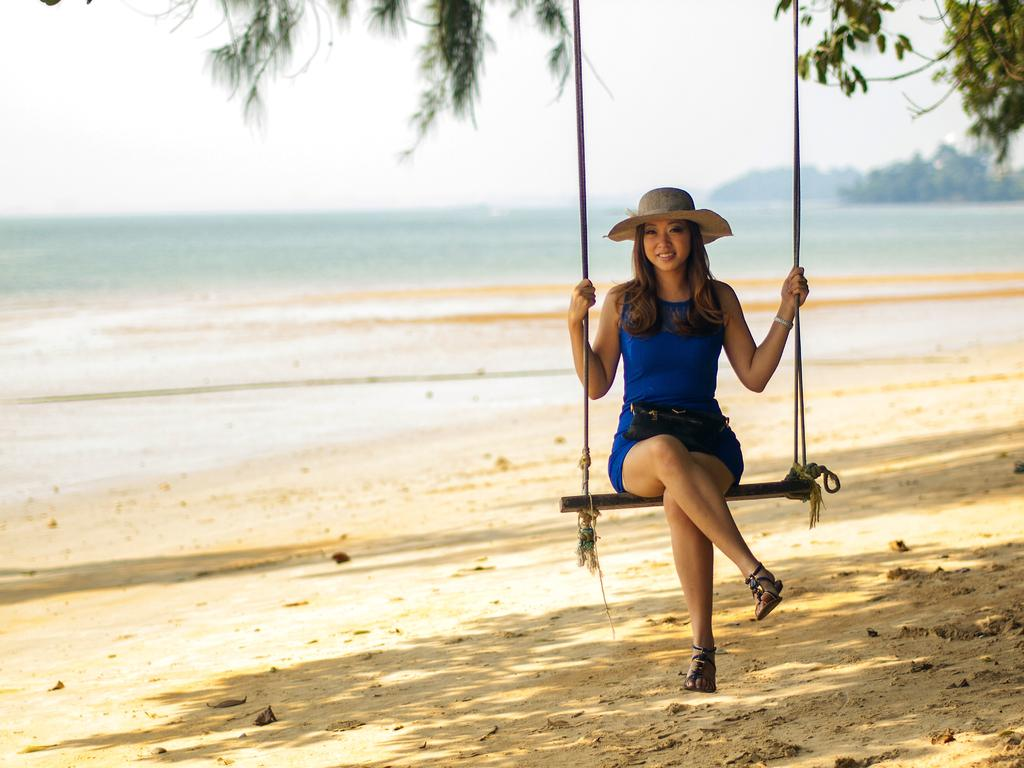What is the woman in the image doing? The woman is sitting in the swing in the image. What is the woman wearing on her head? The woman is wearing a hat. What type of terrain can be seen in the background of the image? There is sand, water, and hills visible in the background of the image. What part of the natural environment is visible in the image? The sky is visible in the background of the image. What type of steel is used to construct the mailbox in the image? There is no mailbox present in the image, so it is not possible to determine the type of steel used in its construction. 